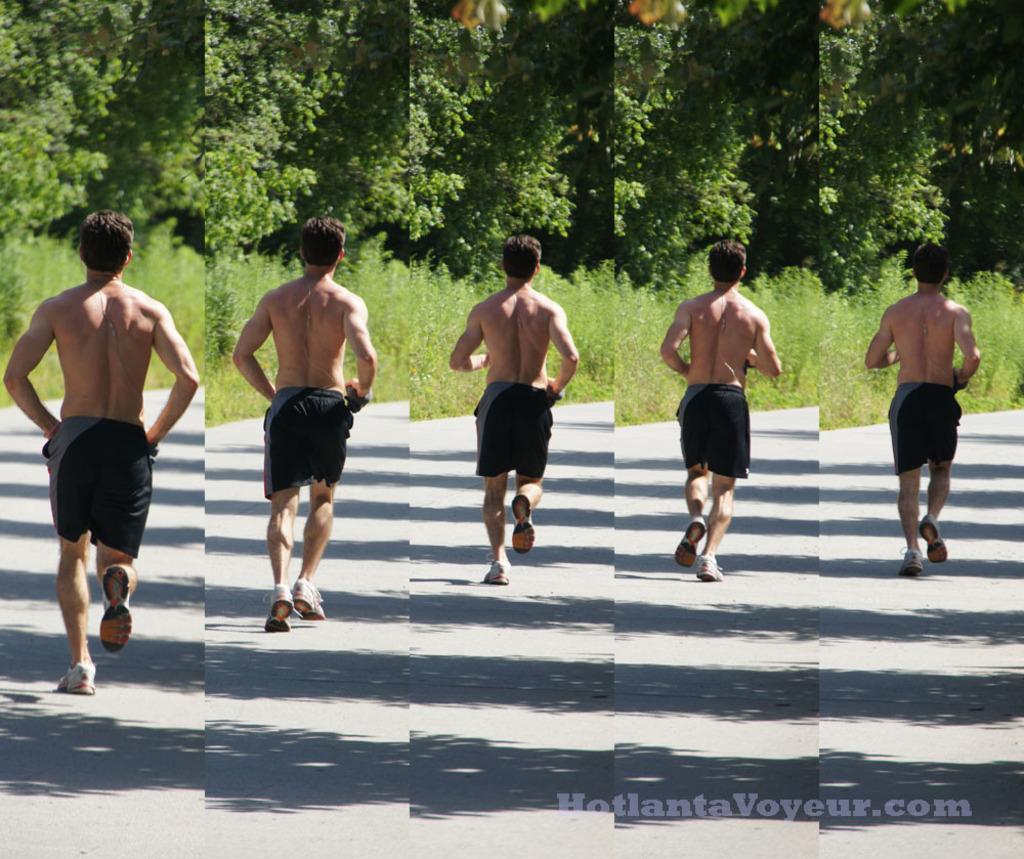Can you describe this image briefly? In the image I can see the collage of five pictures in which there is the picture of a person who is wearing the short and running and also I can see some trees and plants. 